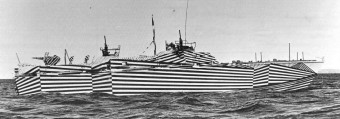How many boats would there be in the image if one additional boat was added in the scence? 4 